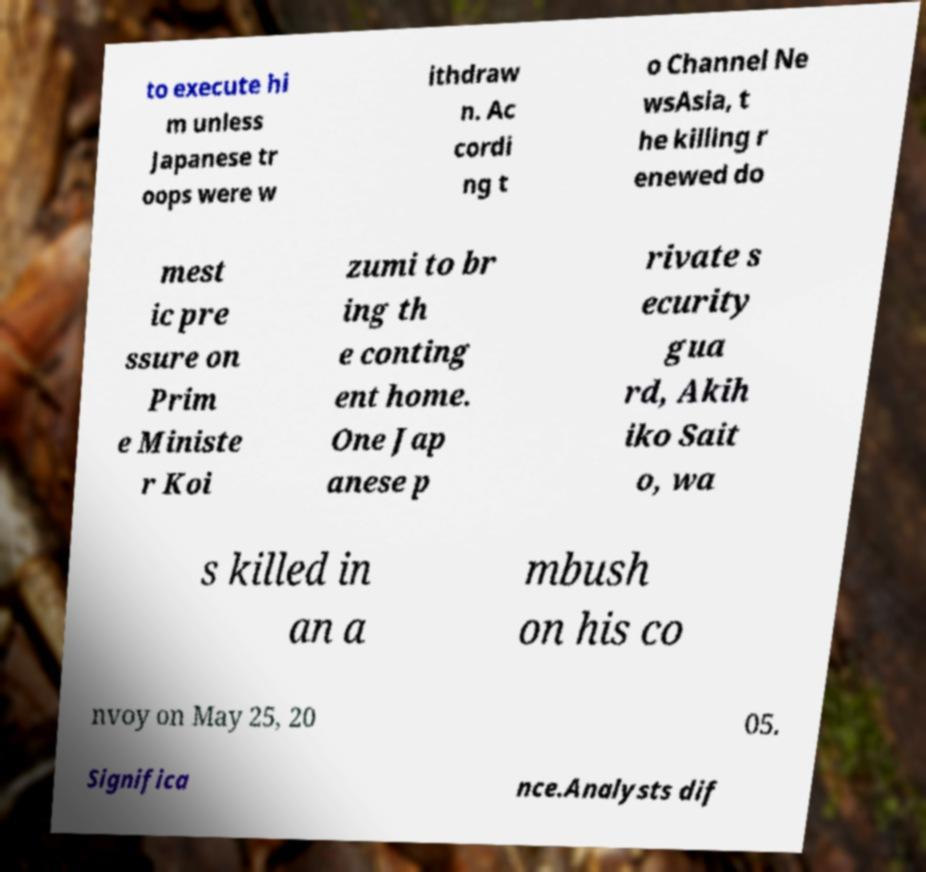Can you accurately transcribe the text from the provided image for me? to execute hi m unless Japanese tr oops were w ithdraw n. Ac cordi ng t o Channel Ne wsAsia, t he killing r enewed do mest ic pre ssure on Prim e Ministe r Koi zumi to br ing th e conting ent home. One Jap anese p rivate s ecurity gua rd, Akih iko Sait o, wa s killed in an a mbush on his co nvoy on May 25, 20 05. Significa nce.Analysts dif 